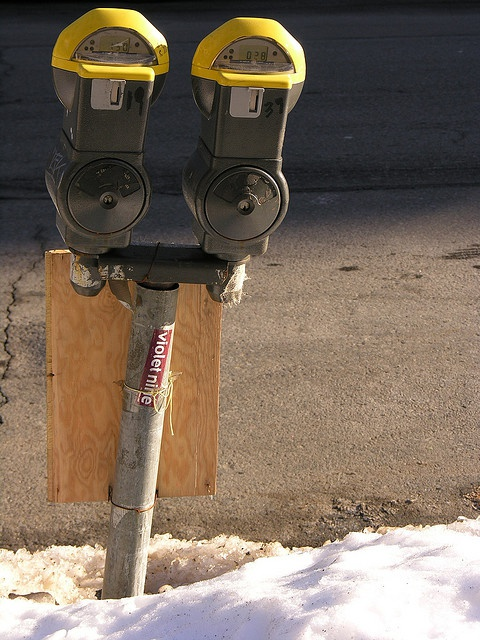Describe the objects in this image and their specific colors. I can see parking meter in black, gray, and olive tones and parking meter in black, gray, and olive tones in this image. 